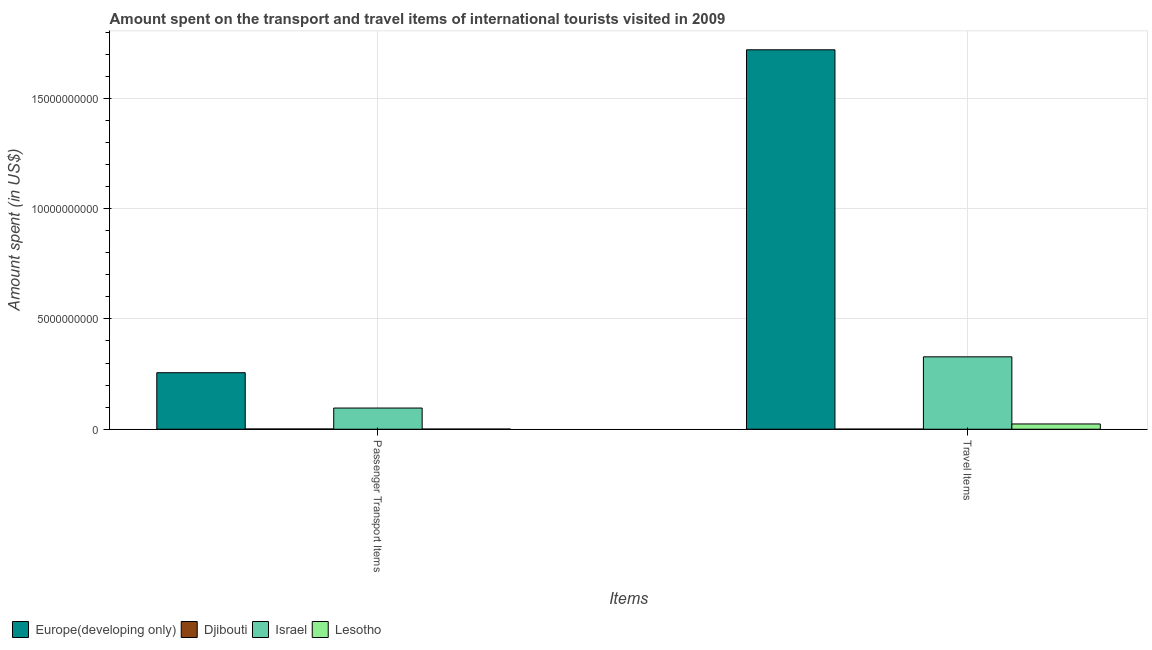How many different coloured bars are there?
Offer a very short reply. 4. Are the number of bars per tick equal to the number of legend labels?
Your response must be concise. Yes. Are the number of bars on each tick of the X-axis equal?
Your response must be concise. Yes. How many bars are there on the 1st tick from the right?
Make the answer very short. 4. What is the label of the 1st group of bars from the left?
Keep it short and to the point. Passenger Transport Items. What is the amount spent in travel items in Israel?
Your response must be concise. 3.28e+09. Across all countries, what is the maximum amount spent on passenger transport items?
Give a very brief answer. 2.56e+09. Across all countries, what is the minimum amount spent on passenger transport items?
Keep it short and to the point. 8.00e+06. In which country was the amount spent in travel items maximum?
Offer a terse response. Europe(developing only). In which country was the amount spent on passenger transport items minimum?
Your answer should be very brief. Lesotho. What is the total amount spent in travel items in the graph?
Make the answer very short. 2.07e+1. What is the difference between the amount spent in travel items in Europe(developing only) and that in Israel?
Your response must be concise. 1.39e+1. What is the difference between the amount spent on passenger transport items in Lesotho and the amount spent in travel items in Israel?
Keep it short and to the point. -3.27e+09. What is the average amount spent on passenger transport items per country?
Offer a terse response. 8.85e+08. What is the difference between the amount spent on passenger transport items and amount spent in travel items in Israel?
Ensure brevity in your answer.  -2.32e+09. What is the ratio of the amount spent in travel items in Israel to that in Europe(developing only)?
Offer a very short reply. 0.19. Is the amount spent on passenger transport items in Israel less than that in Lesotho?
Provide a short and direct response. No. In how many countries, is the amount spent in travel items greater than the average amount spent in travel items taken over all countries?
Give a very brief answer. 1. What does the 2nd bar from the left in Passenger Transport Items represents?
Ensure brevity in your answer.  Djibouti. What does the 1st bar from the right in Travel Items represents?
Your response must be concise. Lesotho. Are all the bars in the graph horizontal?
Provide a succinct answer. No. What is the difference between two consecutive major ticks on the Y-axis?
Keep it short and to the point. 5.00e+09. Are the values on the major ticks of Y-axis written in scientific E-notation?
Your answer should be very brief. No. How many legend labels are there?
Ensure brevity in your answer.  4. What is the title of the graph?
Provide a short and direct response. Amount spent on the transport and travel items of international tourists visited in 2009. Does "Lithuania" appear as one of the legend labels in the graph?
Offer a terse response. No. What is the label or title of the X-axis?
Offer a very short reply. Items. What is the label or title of the Y-axis?
Offer a terse response. Amount spent (in US$). What is the Amount spent (in US$) of Europe(developing only) in Passenger Transport Items?
Ensure brevity in your answer.  2.56e+09. What is the Amount spent (in US$) of Djibouti in Passenger Transport Items?
Ensure brevity in your answer.  1.17e+07. What is the Amount spent (in US$) in Israel in Passenger Transport Items?
Ensure brevity in your answer.  9.60e+08. What is the Amount spent (in US$) in Lesotho in Passenger Transport Items?
Offer a terse response. 8.00e+06. What is the Amount spent (in US$) of Europe(developing only) in Travel Items?
Offer a terse response. 1.72e+1. What is the Amount spent (in US$) in Djibouti in Travel Items?
Your answer should be very brief. 5.80e+06. What is the Amount spent (in US$) of Israel in Travel Items?
Provide a succinct answer. 3.28e+09. What is the Amount spent (in US$) of Lesotho in Travel Items?
Provide a short and direct response. 2.39e+08. Across all Items, what is the maximum Amount spent (in US$) of Europe(developing only)?
Offer a terse response. 1.72e+1. Across all Items, what is the maximum Amount spent (in US$) of Djibouti?
Make the answer very short. 1.17e+07. Across all Items, what is the maximum Amount spent (in US$) of Israel?
Ensure brevity in your answer.  3.28e+09. Across all Items, what is the maximum Amount spent (in US$) in Lesotho?
Your response must be concise. 2.39e+08. Across all Items, what is the minimum Amount spent (in US$) of Europe(developing only)?
Ensure brevity in your answer.  2.56e+09. Across all Items, what is the minimum Amount spent (in US$) of Djibouti?
Provide a succinct answer. 5.80e+06. Across all Items, what is the minimum Amount spent (in US$) in Israel?
Make the answer very short. 9.60e+08. Across all Items, what is the minimum Amount spent (in US$) in Lesotho?
Your answer should be very brief. 8.00e+06. What is the total Amount spent (in US$) of Europe(developing only) in the graph?
Your answer should be compact. 1.98e+1. What is the total Amount spent (in US$) of Djibouti in the graph?
Make the answer very short. 1.75e+07. What is the total Amount spent (in US$) in Israel in the graph?
Ensure brevity in your answer.  4.24e+09. What is the total Amount spent (in US$) in Lesotho in the graph?
Give a very brief answer. 2.47e+08. What is the difference between the Amount spent (in US$) in Europe(developing only) in Passenger Transport Items and that in Travel Items?
Your answer should be compact. -1.46e+1. What is the difference between the Amount spent (in US$) in Djibouti in Passenger Transport Items and that in Travel Items?
Your response must be concise. 5.90e+06. What is the difference between the Amount spent (in US$) of Israel in Passenger Transport Items and that in Travel Items?
Your answer should be compact. -2.32e+09. What is the difference between the Amount spent (in US$) of Lesotho in Passenger Transport Items and that in Travel Items?
Ensure brevity in your answer.  -2.31e+08. What is the difference between the Amount spent (in US$) in Europe(developing only) in Passenger Transport Items and the Amount spent (in US$) in Djibouti in Travel Items?
Ensure brevity in your answer.  2.56e+09. What is the difference between the Amount spent (in US$) in Europe(developing only) in Passenger Transport Items and the Amount spent (in US$) in Israel in Travel Items?
Your answer should be compact. -7.20e+08. What is the difference between the Amount spent (in US$) of Europe(developing only) in Passenger Transport Items and the Amount spent (in US$) of Lesotho in Travel Items?
Offer a terse response. 2.32e+09. What is the difference between the Amount spent (in US$) of Djibouti in Passenger Transport Items and the Amount spent (in US$) of Israel in Travel Items?
Ensure brevity in your answer.  -3.27e+09. What is the difference between the Amount spent (in US$) in Djibouti in Passenger Transport Items and the Amount spent (in US$) in Lesotho in Travel Items?
Provide a short and direct response. -2.27e+08. What is the difference between the Amount spent (in US$) of Israel in Passenger Transport Items and the Amount spent (in US$) of Lesotho in Travel Items?
Your answer should be very brief. 7.21e+08. What is the average Amount spent (in US$) in Europe(developing only) per Items?
Ensure brevity in your answer.  9.88e+09. What is the average Amount spent (in US$) in Djibouti per Items?
Your response must be concise. 8.75e+06. What is the average Amount spent (in US$) in Israel per Items?
Provide a short and direct response. 2.12e+09. What is the average Amount spent (in US$) in Lesotho per Items?
Offer a terse response. 1.24e+08. What is the difference between the Amount spent (in US$) of Europe(developing only) and Amount spent (in US$) of Djibouti in Passenger Transport Items?
Keep it short and to the point. 2.55e+09. What is the difference between the Amount spent (in US$) in Europe(developing only) and Amount spent (in US$) in Israel in Passenger Transport Items?
Your response must be concise. 1.60e+09. What is the difference between the Amount spent (in US$) in Europe(developing only) and Amount spent (in US$) in Lesotho in Passenger Transport Items?
Provide a short and direct response. 2.55e+09. What is the difference between the Amount spent (in US$) in Djibouti and Amount spent (in US$) in Israel in Passenger Transport Items?
Provide a short and direct response. -9.48e+08. What is the difference between the Amount spent (in US$) of Djibouti and Amount spent (in US$) of Lesotho in Passenger Transport Items?
Offer a very short reply. 3.70e+06. What is the difference between the Amount spent (in US$) in Israel and Amount spent (in US$) in Lesotho in Passenger Transport Items?
Keep it short and to the point. 9.52e+08. What is the difference between the Amount spent (in US$) in Europe(developing only) and Amount spent (in US$) in Djibouti in Travel Items?
Offer a terse response. 1.72e+1. What is the difference between the Amount spent (in US$) in Europe(developing only) and Amount spent (in US$) in Israel in Travel Items?
Your answer should be very brief. 1.39e+1. What is the difference between the Amount spent (in US$) in Europe(developing only) and Amount spent (in US$) in Lesotho in Travel Items?
Your response must be concise. 1.70e+1. What is the difference between the Amount spent (in US$) of Djibouti and Amount spent (in US$) of Israel in Travel Items?
Your answer should be very brief. -3.28e+09. What is the difference between the Amount spent (in US$) in Djibouti and Amount spent (in US$) in Lesotho in Travel Items?
Your answer should be very brief. -2.33e+08. What is the difference between the Amount spent (in US$) in Israel and Amount spent (in US$) in Lesotho in Travel Items?
Offer a very short reply. 3.04e+09. What is the ratio of the Amount spent (in US$) in Europe(developing only) in Passenger Transport Items to that in Travel Items?
Offer a terse response. 0.15. What is the ratio of the Amount spent (in US$) in Djibouti in Passenger Transport Items to that in Travel Items?
Give a very brief answer. 2.02. What is the ratio of the Amount spent (in US$) in Israel in Passenger Transport Items to that in Travel Items?
Offer a very short reply. 0.29. What is the ratio of the Amount spent (in US$) in Lesotho in Passenger Transport Items to that in Travel Items?
Offer a very short reply. 0.03. What is the difference between the highest and the second highest Amount spent (in US$) in Europe(developing only)?
Your answer should be very brief. 1.46e+1. What is the difference between the highest and the second highest Amount spent (in US$) of Djibouti?
Your response must be concise. 5.90e+06. What is the difference between the highest and the second highest Amount spent (in US$) in Israel?
Keep it short and to the point. 2.32e+09. What is the difference between the highest and the second highest Amount spent (in US$) of Lesotho?
Give a very brief answer. 2.31e+08. What is the difference between the highest and the lowest Amount spent (in US$) in Europe(developing only)?
Offer a very short reply. 1.46e+1. What is the difference between the highest and the lowest Amount spent (in US$) in Djibouti?
Your answer should be very brief. 5.90e+06. What is the difference between the highest and the lowest Amount spent (in US$) in Israel?
Your answer should be compact. 2.32e+09. What is the difference between the highest and the lowest Amount spent (in US$) of Lesotho?
Make the answer very short. 2.31e+08. 